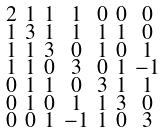Convert formula to latex. <formula><loc_0><loc_0><loc_500><loc_500>\begin{smallmatrix} 2 & 1 & 1 & 1 & 0 & 0 & 0 \\ 1 & 3 & 1 & 1 & 1 & 1 & 0 \\ 1 & 1 & 3 & 0 & 1 & 0 & 1 \\ 1 & 1 & 0 & 3 & 0 & 1 & - 1 \\ 0 & 1 & 1 & 0 & 3 & 1 & 1 \\ 0 & 1 & 0 & 1 & 1 & 3 & 0 \\ 0 & 0 & 1 & - 1 & 1 & 0 & 3 \end{smallmatrix}</formula> 